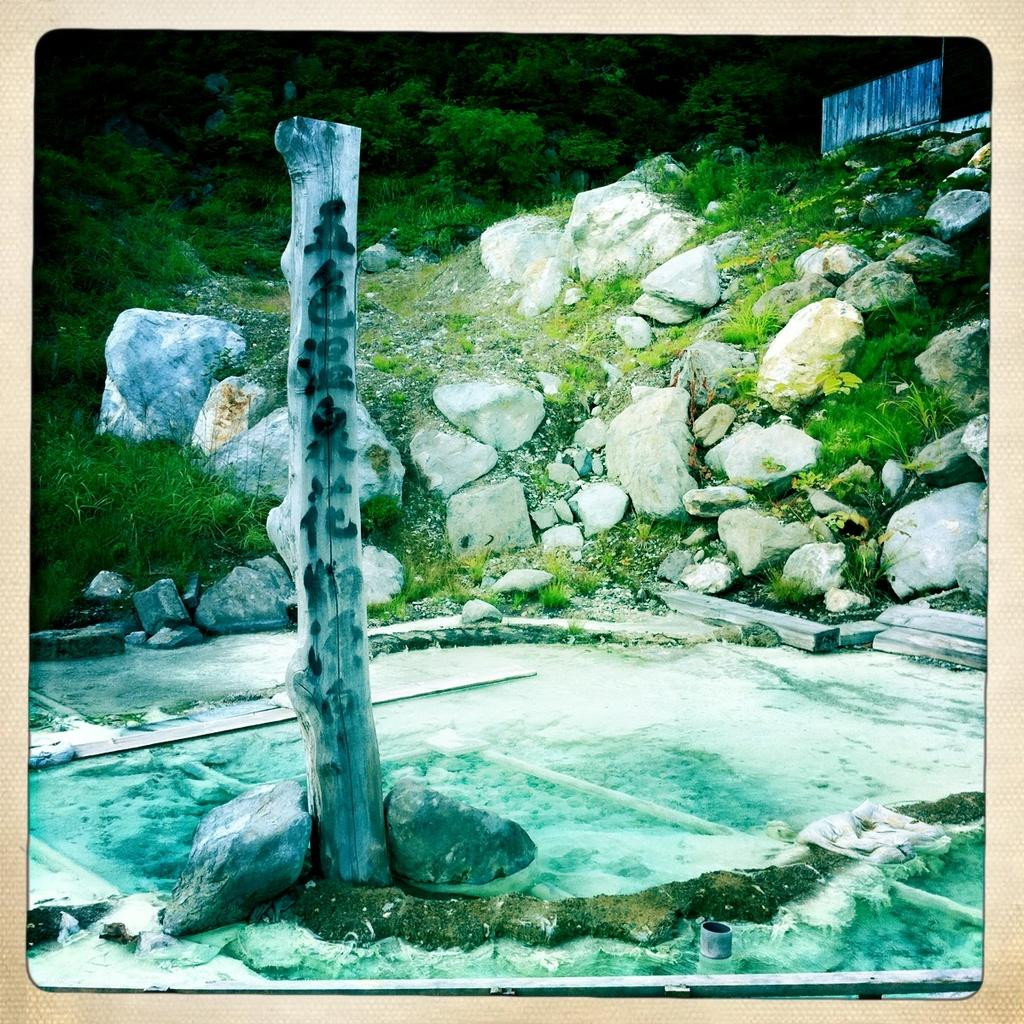What is located in the front of the image? There are stones in the front of the image. What is in the center of the image? There is water in the center of the image. What can be seen in the background of the image? There are trees and stones in the background of the image. What type of vegetation is present on the ground in the image? There is grass on the ground in the image. How many waves can be seen crashing on the shore in the image? There are no waves present in the image; it features stones, water, trees, and grass. What type of pickle is visible in the image? There is no pickle present in the image. 